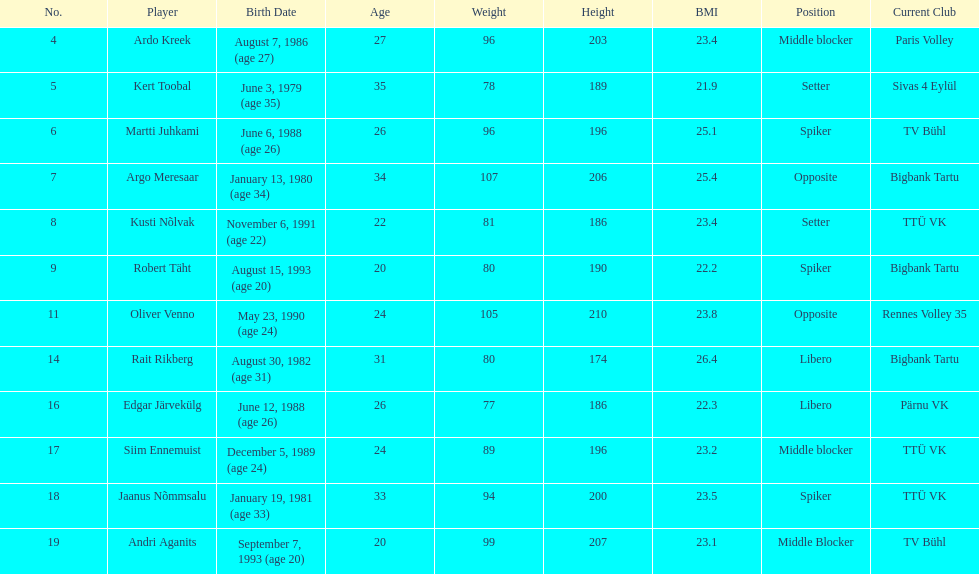Who is the tallest member of estonia's men's national volleyball team? Oliver Venno. 